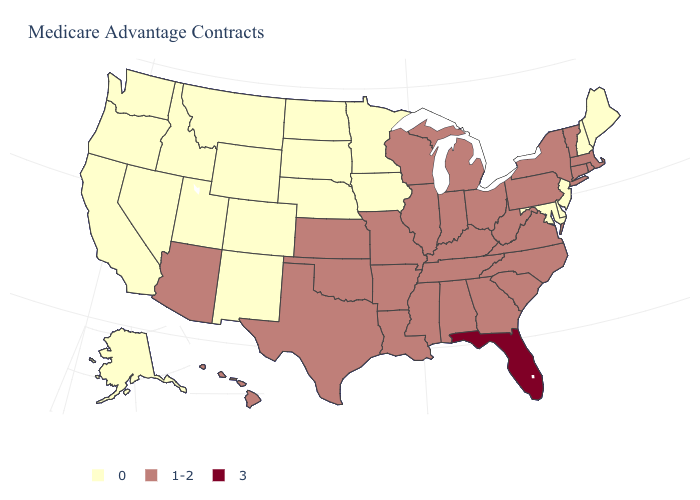Among the states that border North Carolina , which have the highest value?
Short answer required. Georgia, South Carolina, Tennessee, Virginia. Is the legend a continuous bar?
Keep it brief. No. What is the lowest value in the USA?
Answer briefly. 0. What is the value of Idaho?
Answer briefly. 0. What is the highest value in states that border Maine?
Answer briefly. 0. What is the value of South Carolina?
Short answer required. 1-2. Is the legend a continuous bar?
Keep it brief. No. Does the map have missing data?
Quick response, please. No. What is the value of Arkansas?
Answer briefly. 1-2. What is the highest value in the USA?
Be succinct. 3. Is the legend a continuous bar?
Write a very short answer. No. What is the lowest value in the USA?
Concise answer only. 0. Which states have the highest value in the USA?
Give a very brief answer. Florida. Which states have the highest value in the USA?
Short answer required. Florida. Name the states that have a value in the range 0?
Keep it brief. Alaska, California, Colorado, Delaware, Iowa, Idaho, Maryland, Maine, Minnesota, Montana, North Dakota, Nebraska, New Hampshire, New Jersey, New Mexico, Nevada, Oregon, South Dakota, Utah, Washington, Wyoming. 